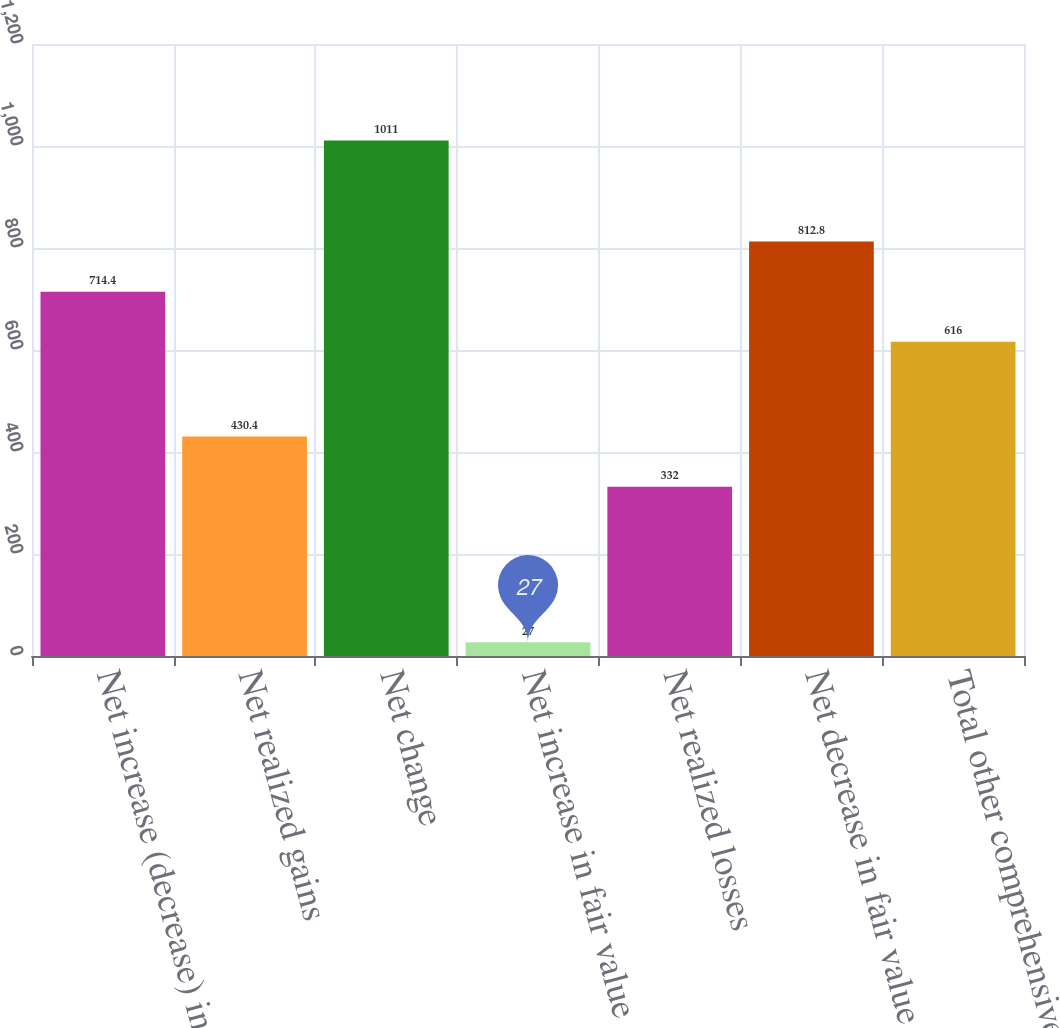<chart> <loc_0><loc_0><loc_500><loc_500><bar_chart><fcel>Net increase (decrease) in<fcel>Net realized gains<fcel>Net change<fcel>Net increase in fair value<fcel>Net realized losses<fcel>Net decrease in fair value<fcel>Total other comprehensive<nl><fcel>714.4<fcel>430.4<fcel>1011<fcel>27<fcel>332<fcel>812.8<fcel>616<nl></chart> 